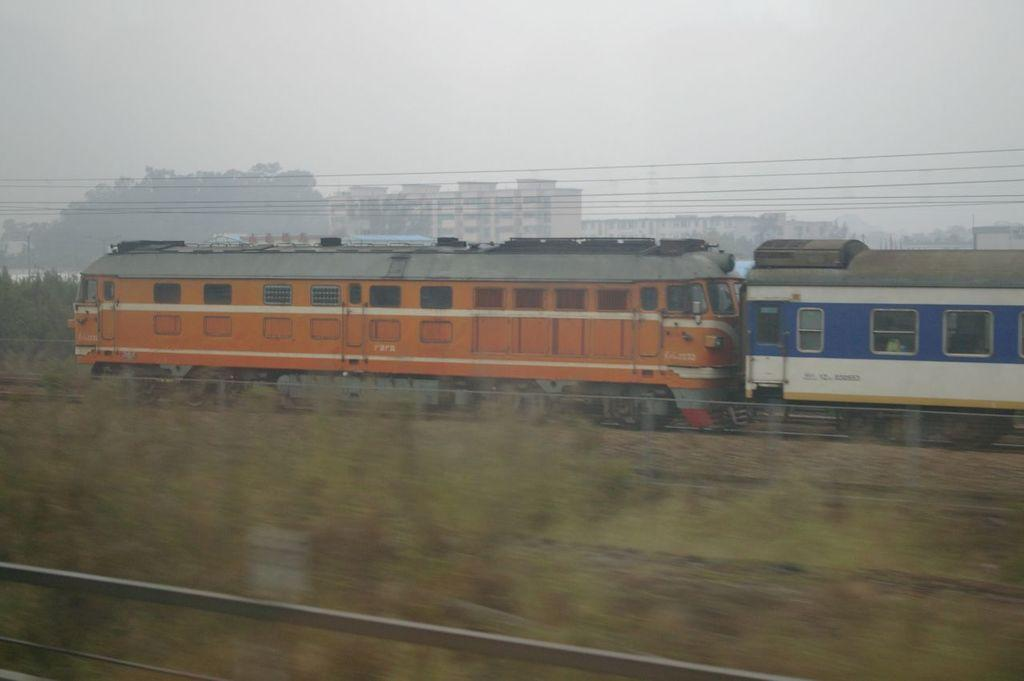What is the main subject of the image? The main subject of the image is a train engine. Is there anything connected to the train engine? Yes, there is a coach attached to the train engine in the image. What is supporting the movement of the train? The train is on tracks, which support its movement. What can be seen in the background of the image? There are buildings in the background of the image. What is present on top of the train? Electrical cables are present on top of the train. How many rifles are visible on the train in the image? There are no rifles present in the image; it features a train engine and a coach on tracks. What type of base is supporting the train in the image? The train is supported by tracks, not a base. 